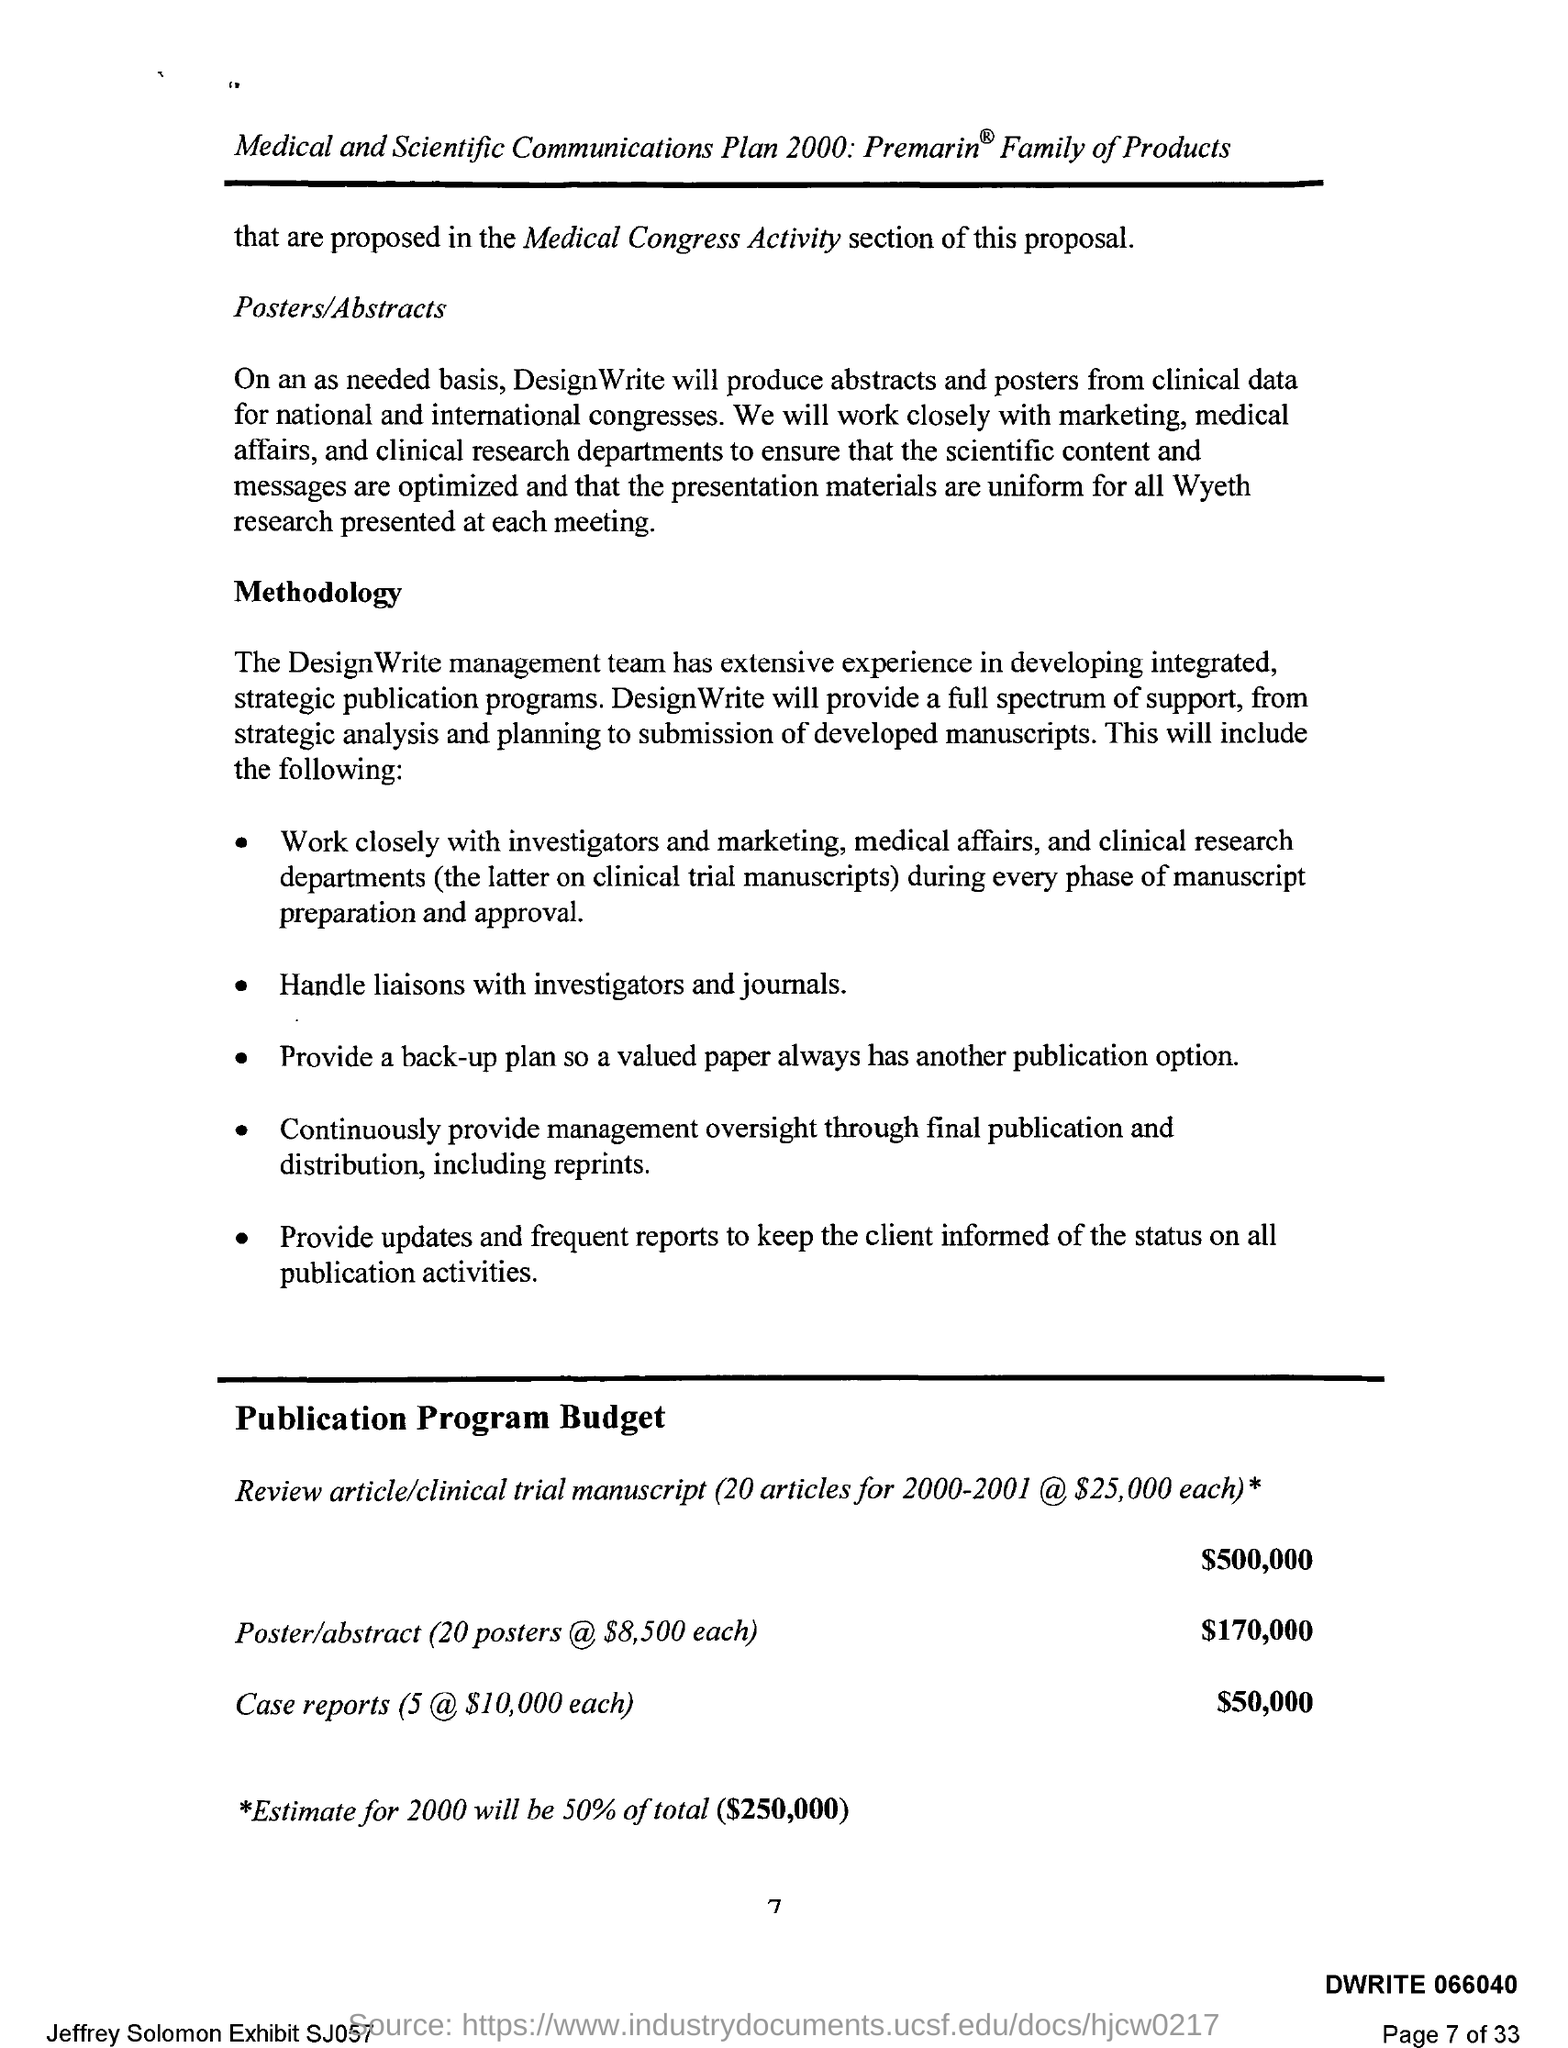Mention a couple of crucial points in this snapshot. The budget for the poster/abstract is $170,000. The budget for case reports is $50,000. The page number is 7. The budget for the review article/clinical trial manuscript is estimated to be $500,000. 